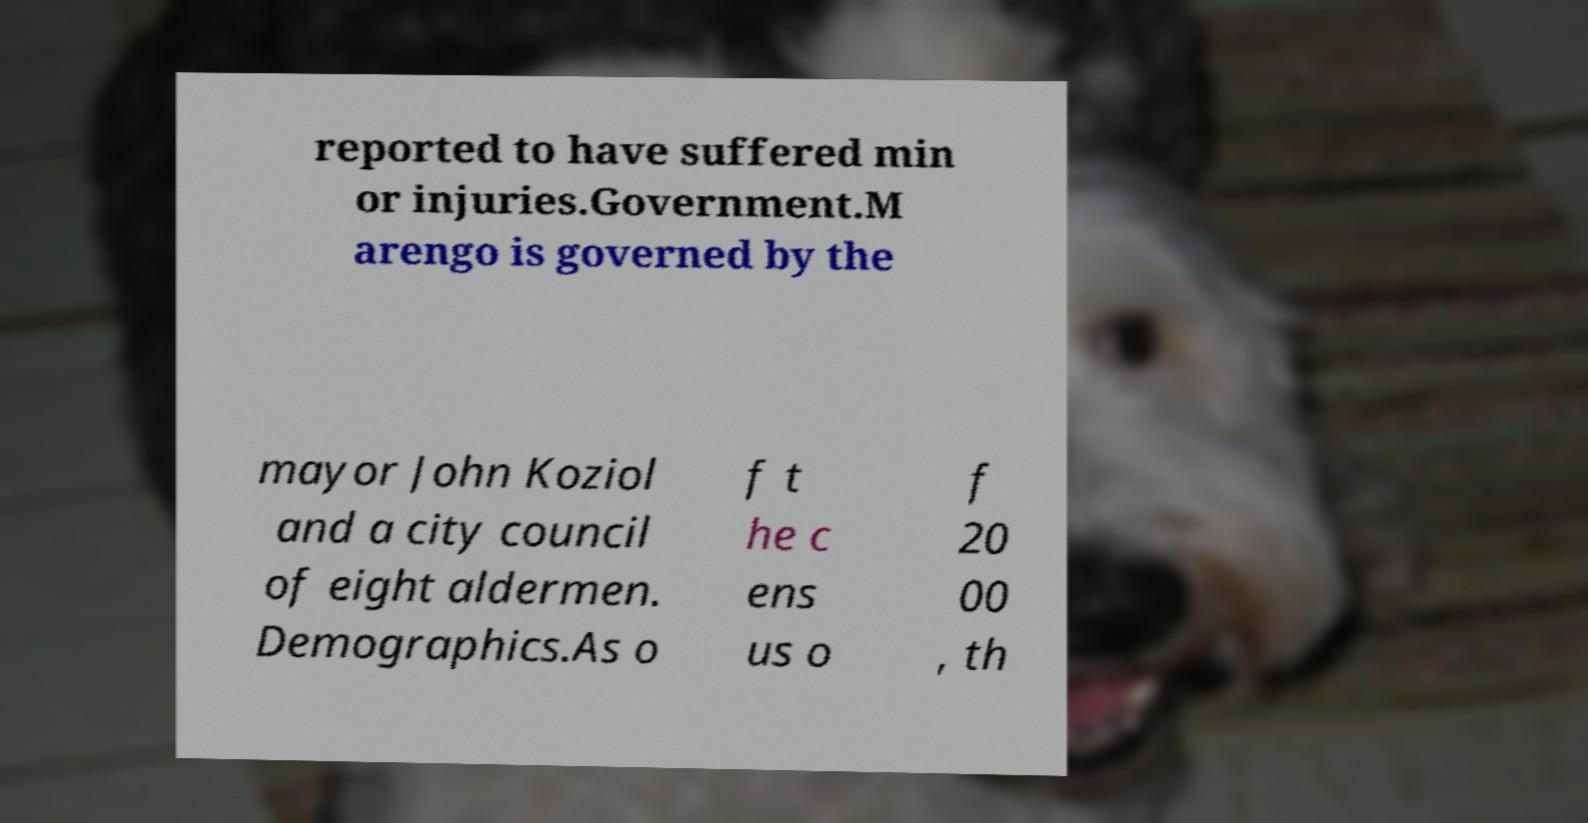Could you assist in decoding the text presented in this image and type it out clearly? reported to have suffered min or injuries.Government.M arengo is governed by the mayor John Koziol and a city council of eight aldermen. Demographics.As o f t he c ens us o f 20 00 , th 